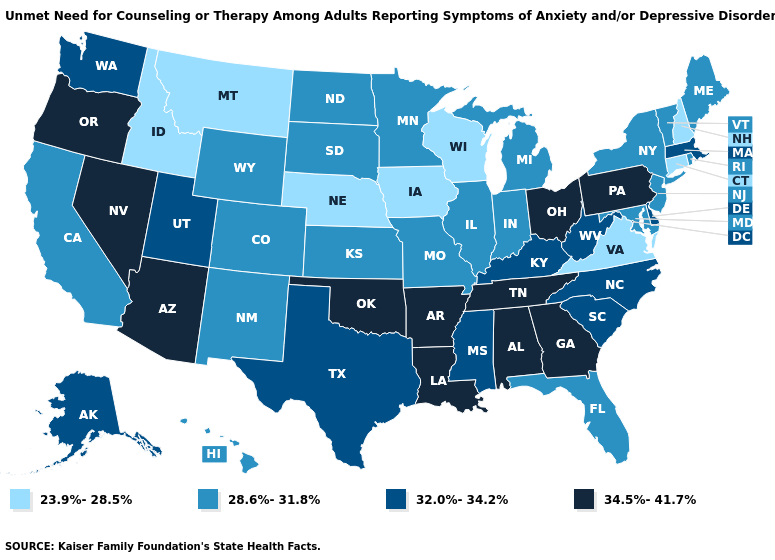Name the states that have a value in the range 28.6%-31.8%?
Give a very brief answer. California, Colorado, Florida, Hawaii, Illinois, Indiana, Kansas, Maine, Maryland, Michigan, Minnesota, Missouri, New Jersey, New Mexico, New York, North Dakota, Rhode Island, South Dakota, Vermont, Wyoming. What is the lowest value in the West?
Answer briefly. 23.9%-28.5%. What is the highest value in states that border Iowa?
Concise answer only. 28.6%-31.8%. Does the map have missing data?
Be succinct. No. What is the value of Michigan?
Short answer required. 28.6%-31.8%. How many symbols are there in the legend?
Give a very brief answer. 4. Among the states that border Wisconsin , which have the highest value?
Short answer required. Illinois, Michigan, Minnesota. Does South Carolina have the highest value in the South?
Answer briefly. No. What is the value of Wyoming?
Keep it brief. 28.6%-31.8%. What is the lowest value in the Northeast?
Quick response, please. 23.9%-28.5%. What is the value of Maryland?
Be succinct. 28.6%-31.8%. Does Washington have the lowest value in the USA?
Answer briefly. No. Name the states that have a value in the range 28.6%-31.8%?
Concise answer only. California, Colorado, Florida, Hawaii, Illinois, Indiana, Kansas, Maine, Maryland, Michigan, Minnesota, Missouri, New Jersey, New Mexico, New York, North Dakota, Rhode Island, South Dakota, Vermont, Wyoming. Does Oregon have a higher value than Louisiana?
Give a very brief answer. No. Does Hawaii have the lowest value in the West?
Write a very short answer. No. 